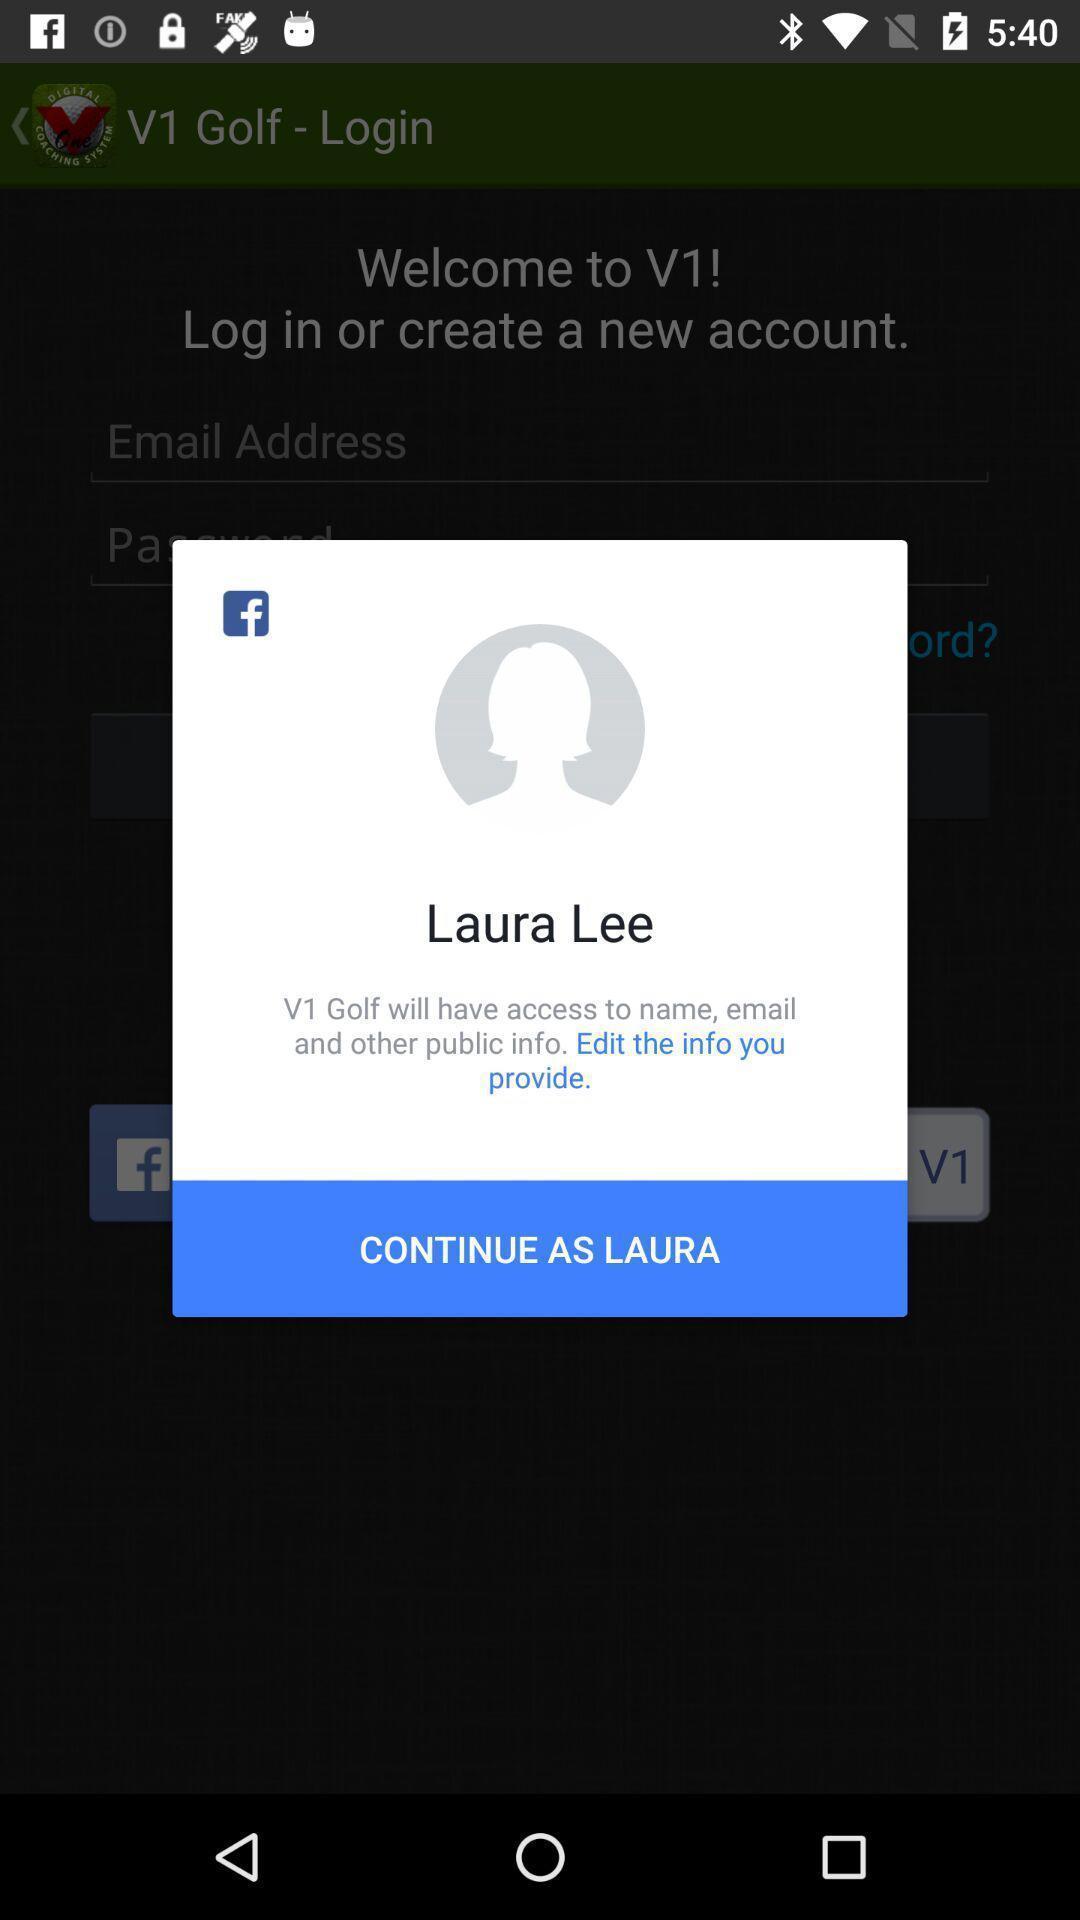Describe this image in words. Pop-up showing profile continuation page of a social app. 